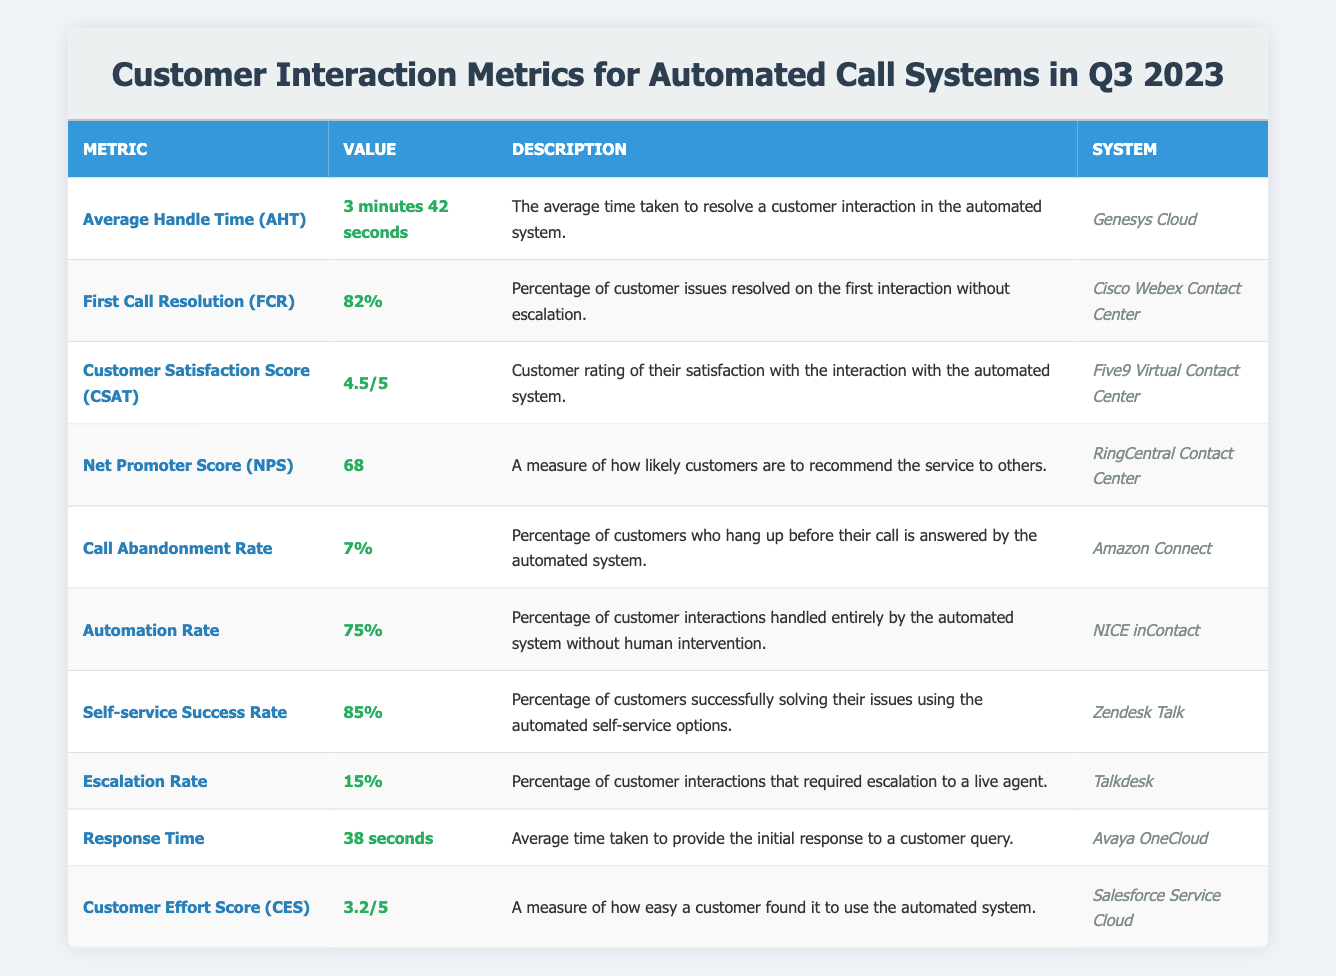What is the Average Handle Time (AHT) for the automated call system? The table lists "Average Handle Time (AHT)" with a value of "3 minutes 42 seconds." Therefore, that is the AHT for the automated system.
Answer: 3 minutes 42 seconds What is the percentage of First Call Resolution (FCR)? The table shows "First Call Resolution (FCR)" with a value of "82%," which directly answers the question.
Answer: 82% Which system has the highest Customer Satisfaction Score (CSAT)? The table indicates that "Five9 Virtual Contact Center" has a CSAT of "4.5/5," which is the highest among all systems listed.
Answer: Five9 Virtual Contact Center Is the Call Abandonment Rate higher than 5%? The table displays a "Call Abandonment Rate" of "7%", which is indeed higher than 5%. Therefore, the statement is true.
Answer: Yes What is the difference in percentage between the Automation Rate and the Self-service Success Rate? The Automation Rate is 75% and the Self-service Success Rate is 85%. The difference is 85% - 75% = 10%.
Answer: 10% What is the average score of the Customer Effort Score (CES) and Customer Satisfaction Score (CSAT)? The CES is 3.2/5 and CSAT is 4.5/5. To find the average, convert the scores to a common scale of out of 5, sum them: (3.2 + 4.5) / 2 = 3.85.
Answer: 3.85 Which automated system had the lowest Escalation Rate? The table has "Talkdesk" listed with an "Escalation Rate" of "15%," and since this is the only value provided, it indicates that no other system had a lower rate.
Answer: Talkdesk If a customer interacts with the system, what is the likelihood they will not need escalation? The Escalation Rate is 15%, which means the likelihood of not needing escalation is 100% - 15% = 85%.
Answer: 85% How many systems report a Customer Satisfaction Score above 4.0? Only "Five9 Virtual Contact Center" with a CSAT of "4.5/5" is listed, so there is just one system.
Answer: 1 What is the relationship between Response Time and Customer Effort Score (CES) based on the provided metrics? The Response Time is 38 seconds, while the CES is rated at 3.2/5. A shorter response time is generally seen as a more positive interaction, which may lead to a higher CES. However, one cannot mathematically quantify the relationship without further data.
Answer: Response Time is shorter, potentially affecting CES positively 